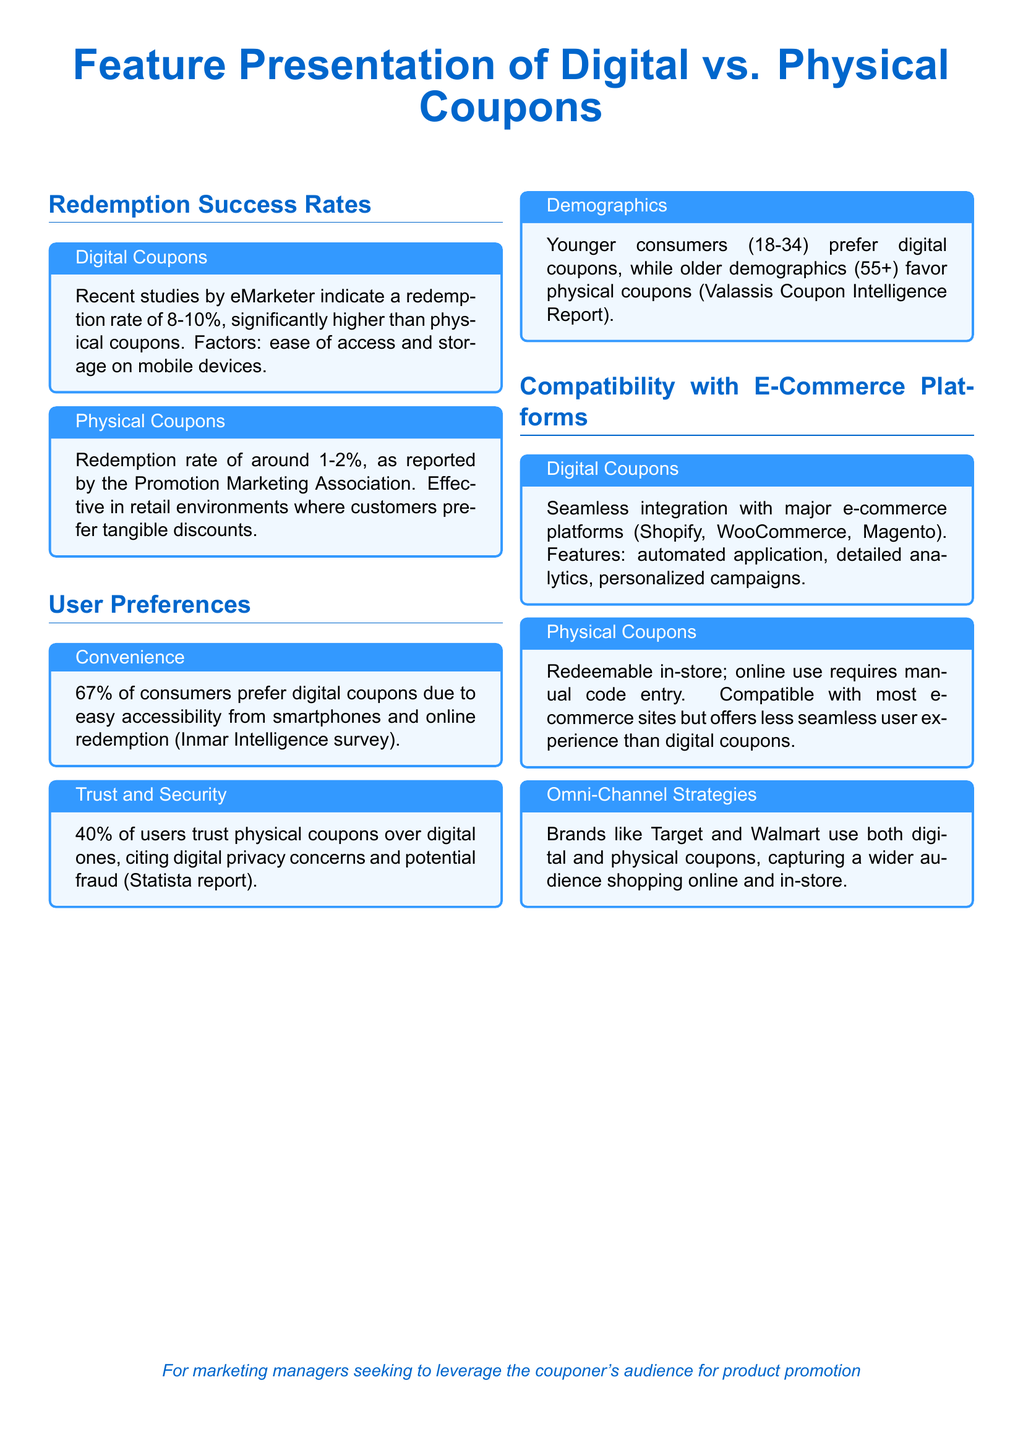What is the redemption rate for digital coupons? The redemption rate for digital coupons is indicated in the document as 8-10%.
Answer: 8-10% What is the redemption rate for physical coupons? The document states that the redemption rate for physical coupons is around 1-2%.
Answer: 1-2% What percentage of consumers prefer digital coupons due to convenience? The document highlights that 67% of consumers prefer digital coupons for their easy accessibility and redemption.
Answer: 67% Which demographic prefers physical coupons? According to the document, older demographics (55+) favor physical coupons.
Answer: Older demographics (55+) What platforms do digital coupons integrate with? The document mentions that digital coupons integrate seamlessly with platforms like Shopify, WooCommerce, and Magento.
Answer: Shopify, WooCommerce, Magento What is a concern for 40% of users regarding digital coupons? The document notes that 40% of users trust physical coupons over digital ones due to digital privacy concerns and potential fraud.
Answer: Digital privacy concerns Which brands use both digital and physical coupons? The document states that brands like Target and Walmart use both types of coupons to capture a wider audience.
Answer: Target and Walmart What was the source of the survey indicating user preferences for digital coupons? The preference for digital coupons is from an Inmar Intelligence survey as stated in the document.
Answer: Inmar Intelligence survey What percentage of users trust physical coupons more than digital according to the document? The document specifies that 40% of users trust physical coupons more than digital ones.
Answer: 40% 